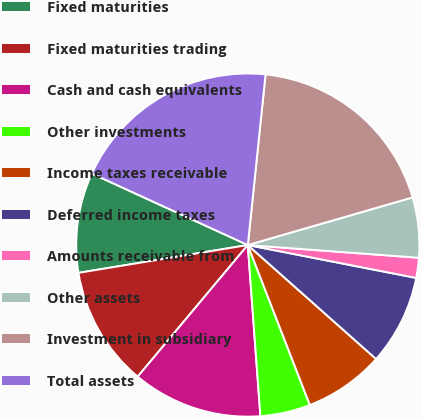Convert chart. <chart><loc_0><loc_0><loc_500><loc_500><pie_chart><fcel>Fixed maturities<fcel>Fixed maturities trading<fcel>Cash and cash equivalents<fcel>Other investments<fcel>Income taxes receivable<fcel>Deferred income taxes<fcel>Amounts receivable from<fcel>Other assets<fcel>Investment in subsidiary<fcel>Total assets<nl><fcel>9.43%<fcel>11.32%<fcel>12.26%<fcel>4.72%<fcel>7.55%<fcel>8.49%<fcel>1.89%<fcel>5.66%<fcel>18.87%<fcel>19.81%<nl></chart> 